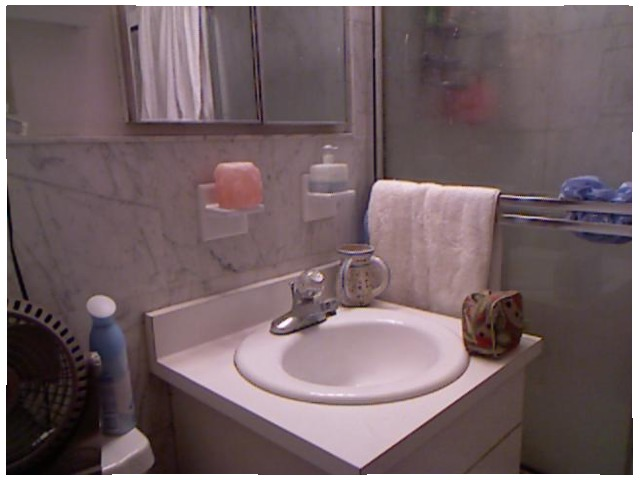<image>
Is the pitcher on the sink? Yes. Looking at the image, I can see the pitcher is positioned on top of the sink, with the sink providing support. Where is the mug in relation to the sink? Is it on the sink? Yes. Looking at the image, I can see the mug is positioned on top of the sink, with the sink providing support. Is there a air freshener to the right of the fan? Yes. From this viewpoint, the air freshener is positioned to the right side relative to the fan. Where is the curtain in relation to the mirror? Is it in the mirror? Yes. The curtain is contained within or inside the mirror, showing a containment relationship. Is there a air freshener in the shower? No. The air freshener is not contained within the shower. These objects have a different spatial relationship. 